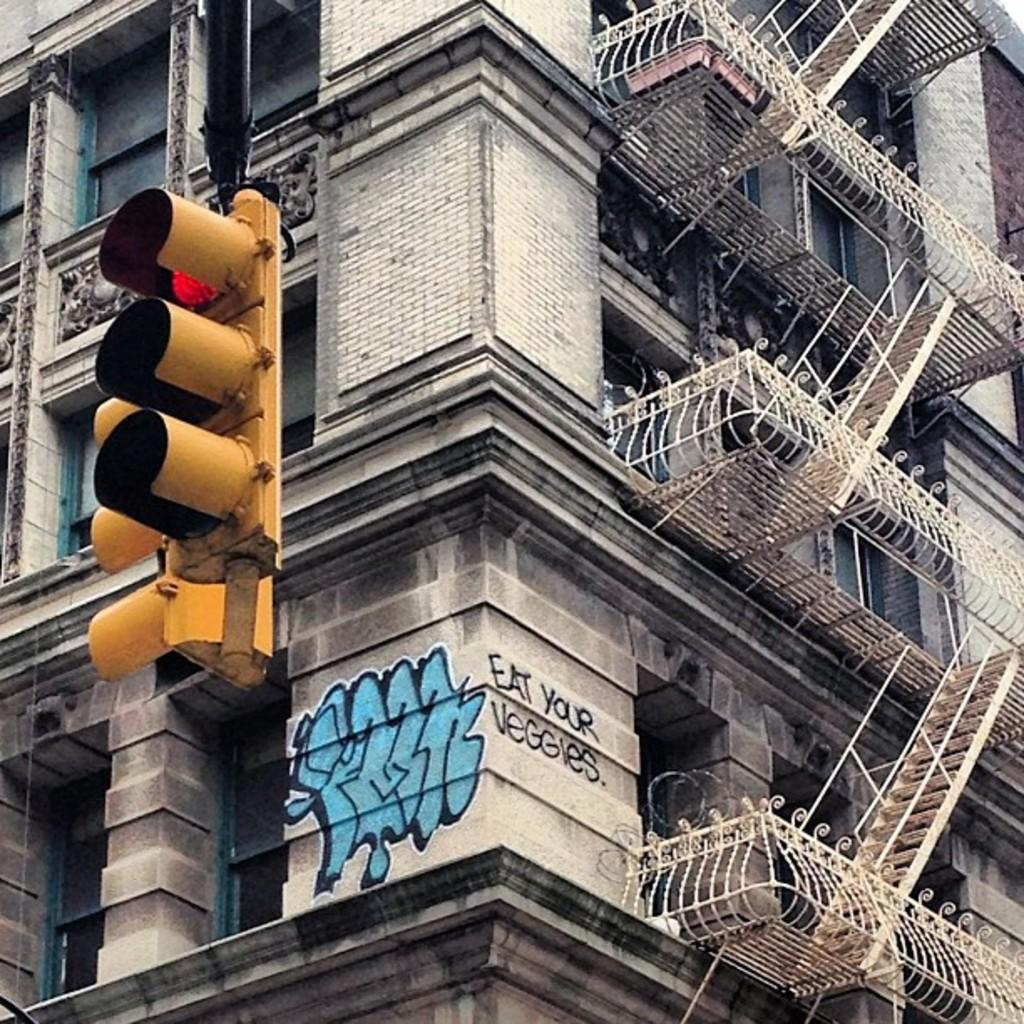What type of structure is present in the image? There is a building in the image. What architectural features can be seen on the building? The building has pillars and a staircase. Is there any text visible in the image? Yes, there is some text visible in the image. What can be found on a wall inside the building? There is a picture on a wall in the image. What can be seen near the building in the image? There are traffic lights in the image. What type of bucket is being used to protest in the image? There is no bucket or protest present in the image. Can you describe the ear of the person holding the bucket in the image? There is no person holding a bucket or any ears visible in the image. 